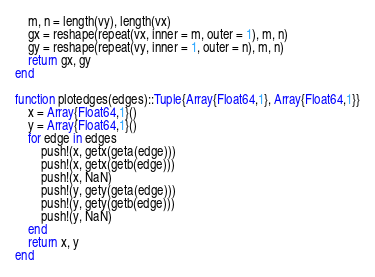Convert code to text. <code><loc_0><loc_0><loc_500><loc_500><_Julia_>    m, n = length(vy), length(vx)
    gx = reshape(repeat(vx, inner = m, outer = 1), m, n)
    gy = reshape(repeat(vy, inner = 1, outer = n), m, n)
    return gx, gy
end

function plotedges(edges)::Tuple{Array{Float64,1}, Array{Float64,1}}
    x = Array{Float64,1}()
    y = Array{Float64,1}()
    for edge in edges
        push!(x, getx(geta(edge)))
        push!(x, getx(getb(edge)))
        push!(x, NaN)
        push!(y, gety(geta(edge)))
        push!(y, gety(getb(edge)))
        push!(y, NaN)
    end
    return x, y
end
</code> 